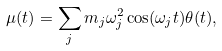<formula> <loc_0><loc_0><loc_500><loc_500>\mu ( t ) = \sum _ { j } m _ { j } \omega ^ { 2 } _ { j } \cos ( \omega _ { j } t ) \theta ( t ) ,</formula> 